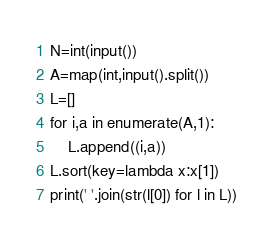Convert code to text. <code><loc_0><loc_0><loc_500><loc_500><_Python_>N=int(input())
A=map(int,input().split())
L=[]
for i,a in enumerate(A,1):
    L.append((i,a))
L.sort(key=lambda x:x[1])
print(' '.join(str(l[0]) for l in L))</code> 